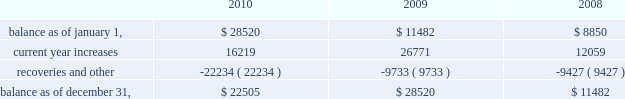American tower corporation and subsidiaries notes to consolidated financial statements recognizing customer revenue , the company must assess the collectability of both the amounts billed and the portion recognized on a straight-line basis .
This assessment takes customer credit risk and business and industry conditions into consideration to ultimately determine the collectability of the amounts billed .
To the extent the amounts , based on management 2019s estimates , may not be collectible , recognition is deferred until such point as the uncertainty is resolved .
Any amounts which were previously recognized as revenue and subsequently determined to be uncollectible are charged to bad debt expense .
Accounts receivable are reported net of allowances for doubtful accounts related to estimated losses resulting from a customer 2019s inability to make required payments and reserves for amounts invoiced whose collectability is not reasonably assured .
These allowances are generally estimated based on payment patterns , days past due and collection history , and incorporate changes in economic conditions that may not be reflected in historical trends , such as customers in bankruptcy , liquidation or reorganization .
Receivables are written-off against the allowances when they are determined uncollectible .
Such determination includes analysis and consideration of the particular conditions of the account .
Changes in the allowances were as follows for the years ended december 31 , ( in thousands ) : .
The company 2019s largest international customer is iusacell , which is the brand name under which a group of companies controlled by grupo iusacell , s.a .
De c.v .
( 201cgrupo iusacell 201d ) operates .
Iusacell represented approximately 4% ( 4 % ) of the company 2019s total revenue for the year ended december 31 , 2010 .
Grupo iusacell has been engaged in a refinancing of a majority of its u.s .
Dollar denominated debt , and in connection with this process , two of the legal entities of the group , including grupo iusacell , voluntarily filed for a pre-packaged concurso mercantil ( a process substantially equivalent to chapter 11 of u.s .
Bankruptcy law ) with the backing of a majority of their financial creditors in december 2010 .
As of december 31 , 2010 , iusacell notes receivable , net , and related assets ( which include financing lease commitments and a deferred rent asset that are primarily long-term in nature ) were $ 19.7 million and $ 51.2 million , respectively .
Functional currency 2014as a result of changes to the organizational structure of the company 2019s subsidiaries in latin america in 2010 , the company determined that effective january 1 , 2010 , the functional currency of its foreign subsidiary in brazil is the brazilian real .
From that point forward , all assets and liabilities held by the subsidiary in brazil are translated into u.s .
Dollars at the exchange rate in effect at the end of the applicable reporting period .
Revenues and expenses are translated at the average monthly exchange rates and the cumulative translation effect is included in stockholders 2019 equity .
The change in functional currency from u.s .
Dollars to brazilian real gave rise to an increase in the net value of certain non-monetary assets and liabilities .
The aggregate impact on such assets and liabilities was $ 39.8 million with an offsetting increase in accumulated other comprehensive income ( loss ) .
As a result of the renegotiation of the company 2019s agreements with its largest international customer , iusacell , which included , among other changes , converting all of iusacell 2019s contractual obligations to the company from u.s .
Dollars to mexican pesos , the company has determined that effective april 1 , 2010 , the functional currency of certain of its foreign subsidiaries in mexico is the mexican peso .
From that point forward , all assets and liabilities held by those subsidiaries in mexico are translated into u.s .
Dollars at the exchange rate in effect at the end of the applicable reporting period .
Revenues and expenses are translated at the average monthly exchange rates and the cumulative translation effect is included in stockholders 2019 equity .
The change in functional .
What is the percentage change in the balance of allowances from 2009 to 2010? 
Computations: ((22505 - 28520) / 28520)
Answer: -0.2109. 